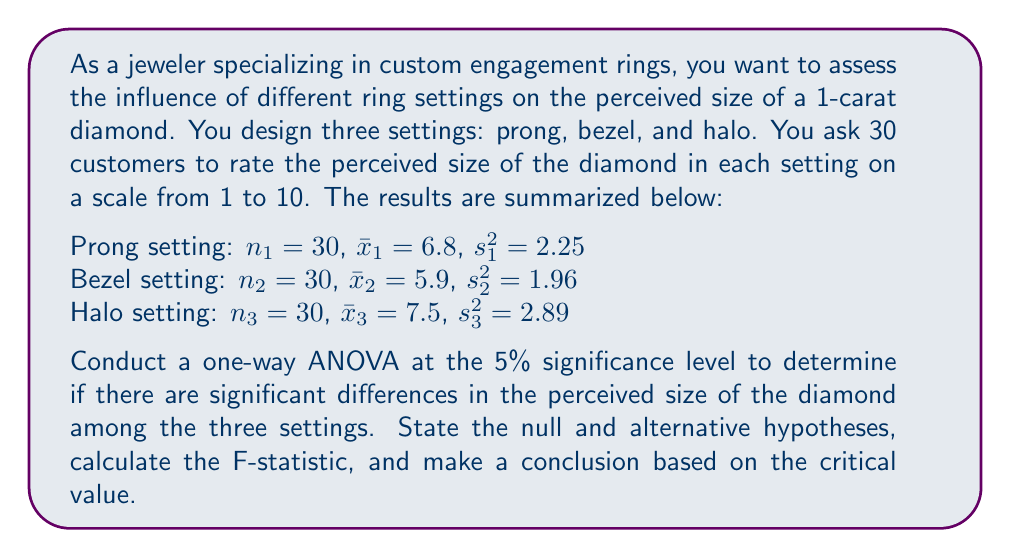Can you solve this math problem? To conduct a one-way ANOVA, we'll follow these steps:

1) State the null and alternative hypotheses:
   $H_0: \mu_1 = \mu_2 = \mu_3$ (no difference in means)
   $H_a:$ At least one mean is different

2) Calculate the total sum of squares (SST), between-group sum of squares (SSB), and within-group sum of squares (SSW):

   SST = SSB + SSW

   SSB = $n_1(\bar{x}_1 - \bar{x})^2 + n_2(\bar{x}_2 - \bar{x})^2 + n_3(\bar{x}_3 - \bar{x})^2$
   
   where $\bar{x} = \frac{n_1\bar{x}_1 + n_2\bar{x}_2 + n_3\bar{x}_3}{n_1 + n_2 + n_3}$

   $\bar{x} = \frac{30(6.8) + 30(5.9) + 30(7.5)}{90} = 6.73$

   SSB = $30(6.8 - 6.73)^2 + 30(5.9 - 6.73)^2 + 30(7.5 - 6.73)^2 = 45.62$

   SSW = $(n_1 - 1)s_1^2 + (n_2 - 1)s_2^2 + (n_3 - 1)s_3^2$
       = $29(2.25) + 29(1.96) + 29(2.89) = 205.9$

3) Calculate degrees of freedom:
   df(between) = k - 1 = 3 - 1 = 2
   df(within) = N - k = 90 - 3 = 87
   where k is the number of groups and N is the total sample size

4) Calculate mean squares:
   MSB = SSB / df(between) = 45.62 / 2 = 22.81
   MSW = SSW / df(within) = 205.9 / 87 = 2.37

5) Calculate the F-statistic:
   F = MSB / MSW = 22.81 / 2.37 = 9.62

6) Find the critical F-value:
   For α = 0.05, df(between) = 2, and df(within) = 87, 
   F-critical ≈ 3.10 (from F-distribution table)

7) Compare F-statistic to F-critical:
   Since 9.62 > 3.10, we reject the null hypothesis.
Answer: Reject the null hypothesis. There is sufficient evidence at the 5% significance level to conclude that there are significant differences in the perceived size of the diamond among the three settings (F = 9.62, p < 0.05). 